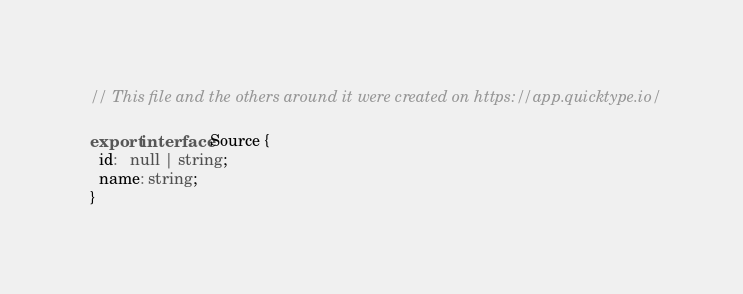<code> <loc_0><loc_0><loc_500><loc_500><_TypeScript_>// This file and the others around it were created on https://app.quicktype.io/

export interface Source {
  id:   null | string;
  name: string;
}</code> 